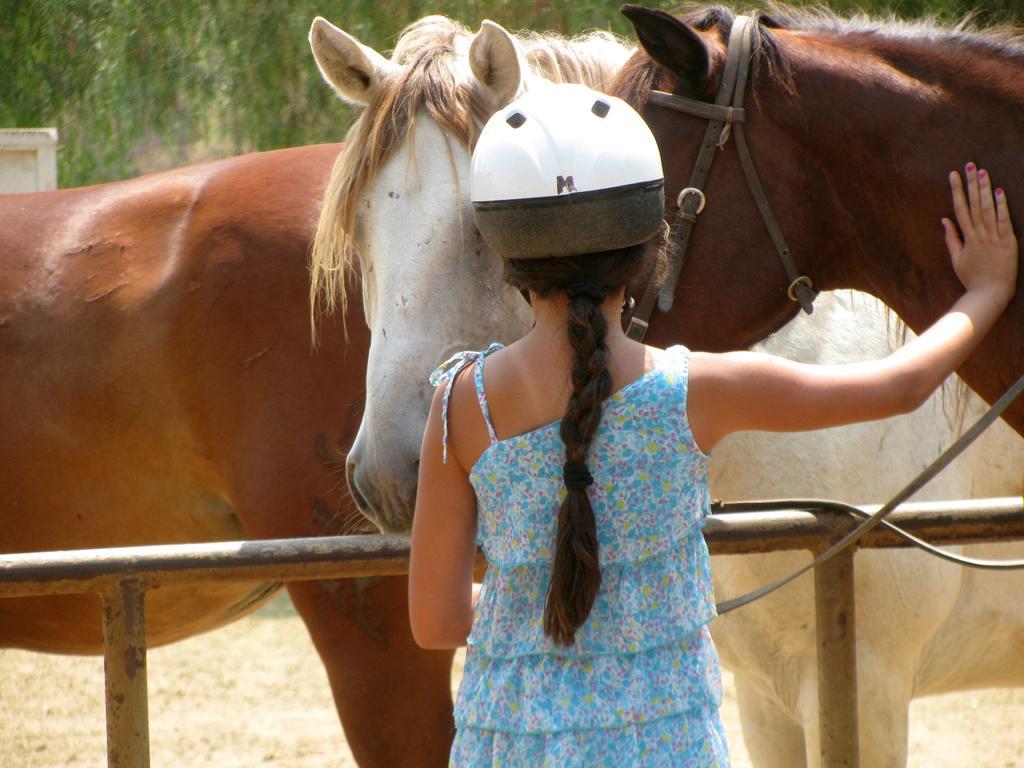Could you give a brief overview of what you see in this image? This girl wore helmet. In-front of this girl there are horses. Far there are trees. 